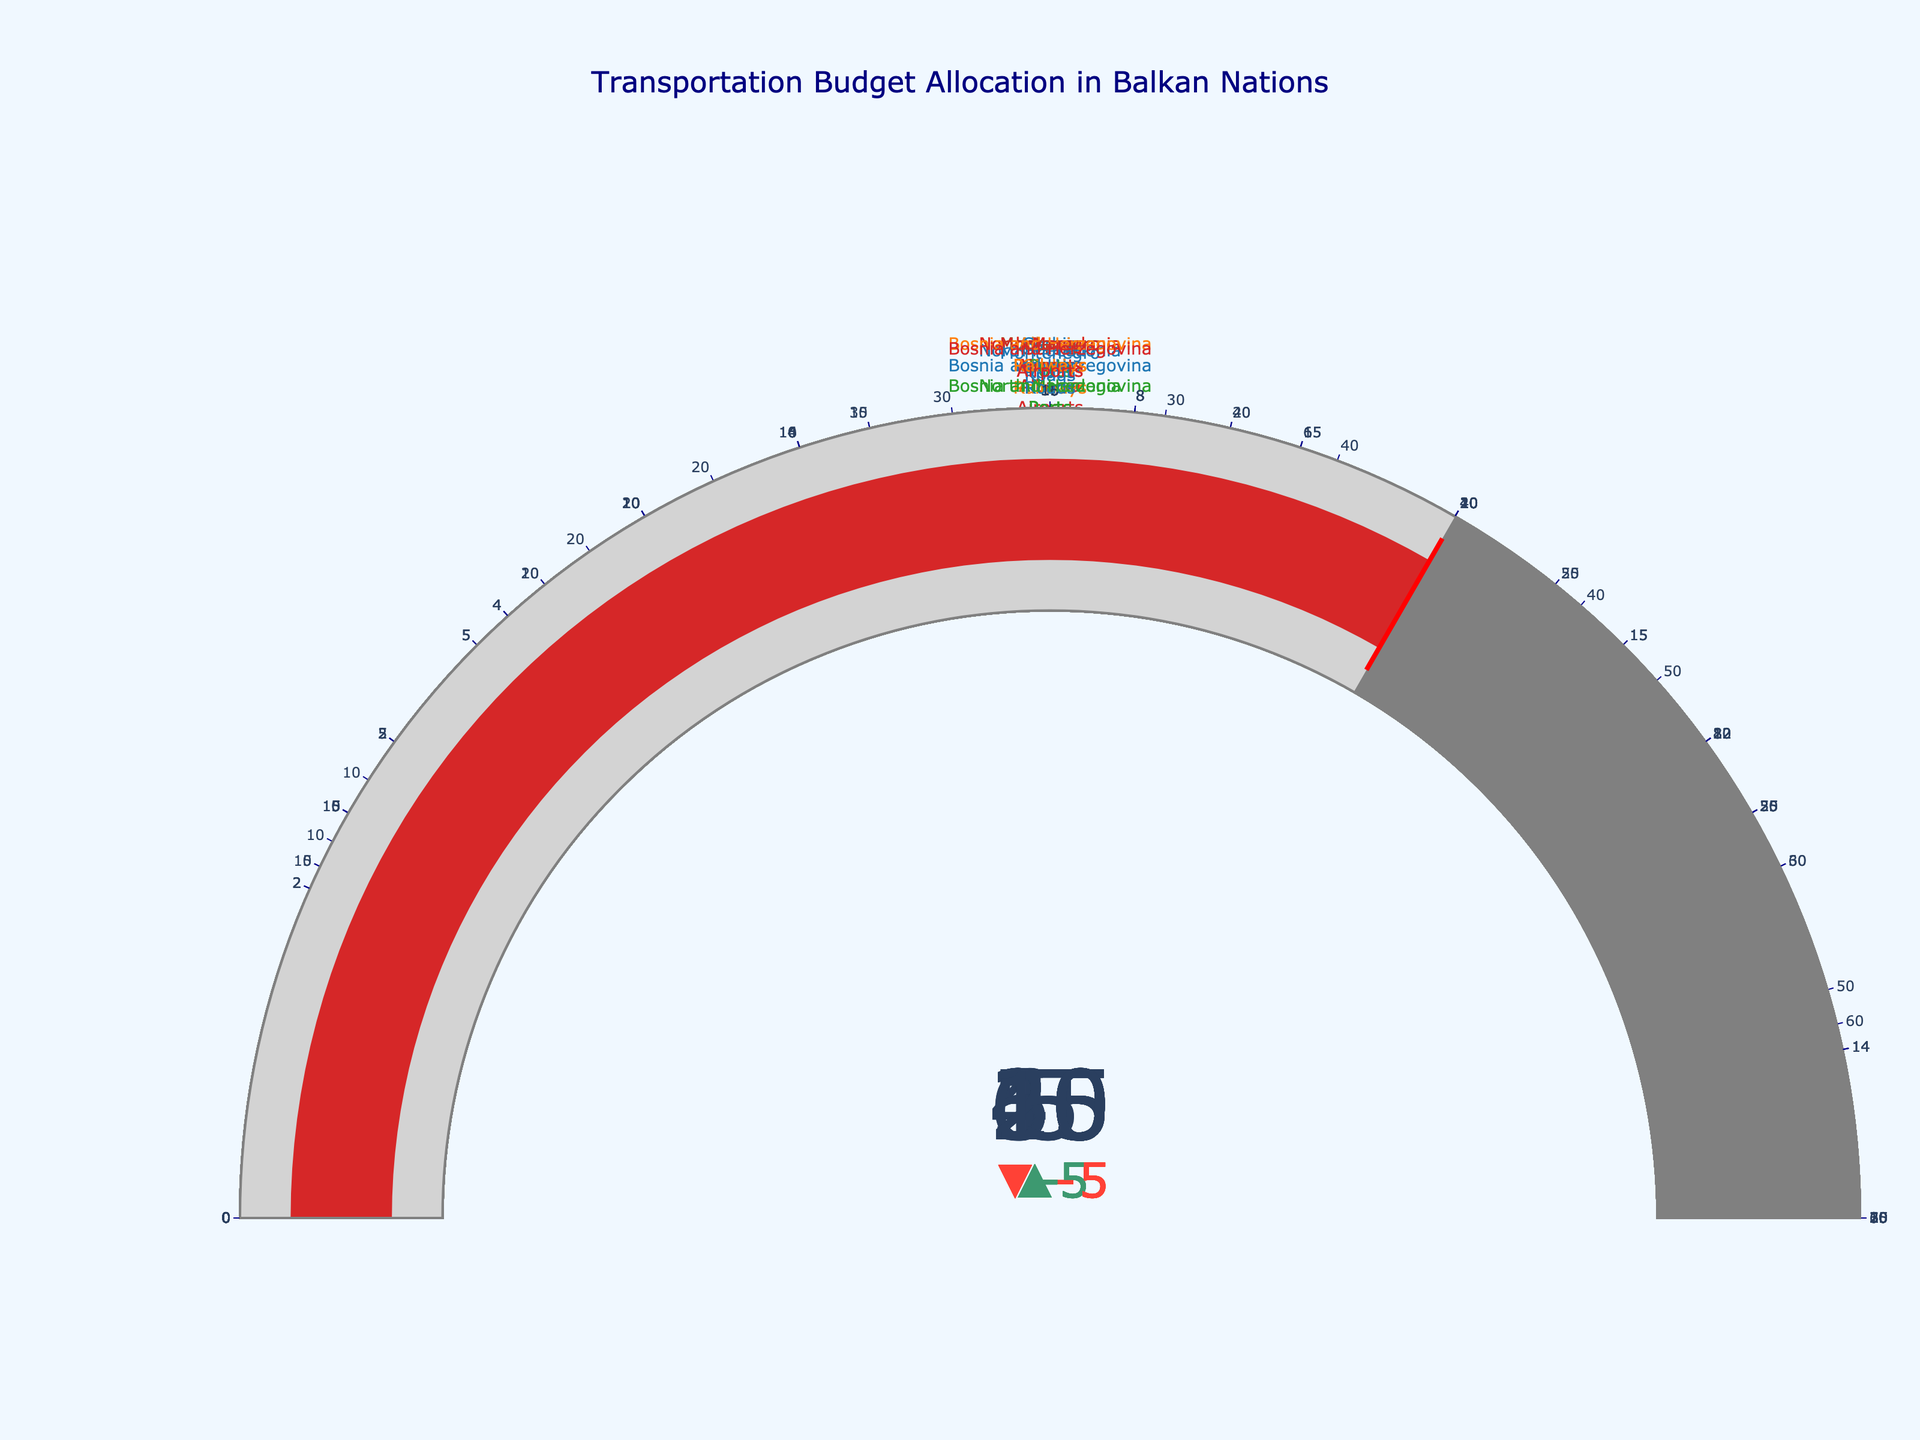What is the title of the figure? The title is often at the top of the figure, prominently displayed to give an overview of what the figure represents. Here, it is written in a larger and differently colored font.
Answer: Transportation Budget Allocation in Balkan Nations Which country has allocated the highest percentage of its transportation budget to roads? Look for the bullet chart representing the budget percentage allocation to roads for each country. Identify the bar with the highest value for actual percentage.
Answer: Bosnia and Herzegovina What is the actual percentage of budget allocation for railways in Serbia? Locate the section for Serbia and then find the bar related to railways. Read the actual percentage value displayed.
Answer: 25 How much higher is Albania's actual budget allocation for ports compared to its target allocation for ports? Locate the values for Albania's ports. Subtract the target percentage from the actual percentage: 20 - 15.
Answer: 5 Among all the countries, which infrastructure type has the least variation between actual and target budget allocation? Measure the difference between actual and target allocations for each infrastructure type for all countries. Identify the smallest difference.
Answer: Ports in Serbia Which country has the closest actual budget allocation to its target for airports? Look at the delta values (difference between actual and target) for the airports in each country. Identify the smallest delta.
Answer: Serbia, North Macedonia, and Bosnia and Herzegovina (tie) What is the combined actual budget allocation for roads and airports in Montenegro? Find Montenegro's actual percentages for roads and airports. Add these values: 50 (roads) + 15 (airports).
Answer: 65 How does the target budget allocation for railways in Albania compare to that in Bosnia and Herzegovina? Find the target percentages for railways for Albania and Bosnia and Herzegovina, then compare them: 20 (Albania) vs. 25 (Bosnia and Herzegovina).
Answer: Albania's target is lower Which country has the maximum number of infrastructure types where the actual percentage exceeds the target? For each country, count the instances where the actual percentage is greater than the target for each infrastructure type. Identify the country with the highest count.
Answer: Albania 